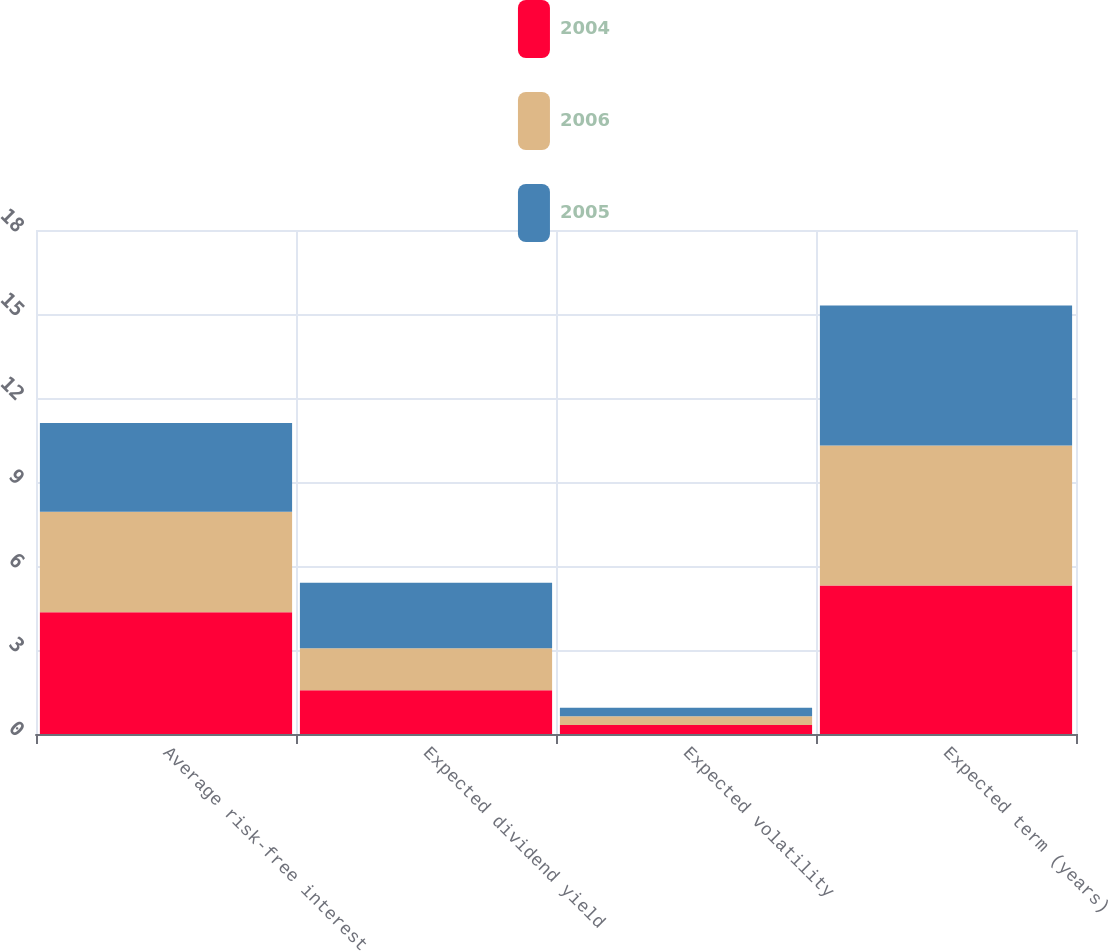<chart> <loc_0><loc_0><loc_500><loc_500><stacked_bar_chart><ecel><fcel>Average risk-free interest<fcel>Expected dividend yield<fcel>Expected volatility<fcel>Expected term (years)<nl><fcel>2004<fcel>4.35<fcel>1.56<fcel>0.32<fcel>5.3<nl><fcel>2006<fcel>3.59<fcel>1.5<fcel>0.31<fcel>5<nl><fcel>2005<fcel>3.17<fcel>2.34<fcel>0.31<fcel>5<nl></chart> 